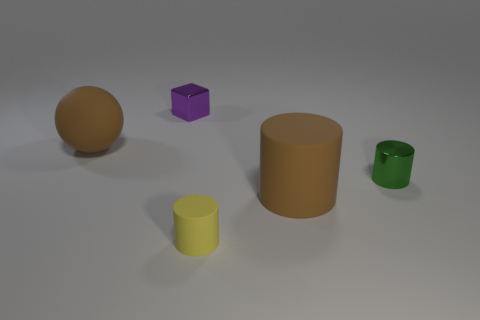Add 3 tiny red metallic objects. How many objects exist? 8 Subtract all cylinders. How many objects are left? 2 Add 5 tiny yellow things. How many tiny yellow things exist? 6 Subtract 0 green cubes. How many objects are left? 5 Subtract all large gray metallic things. Subtract all rubber spheres. How many objects are left? 4 Add 5 large things. How many large things are left? 7 